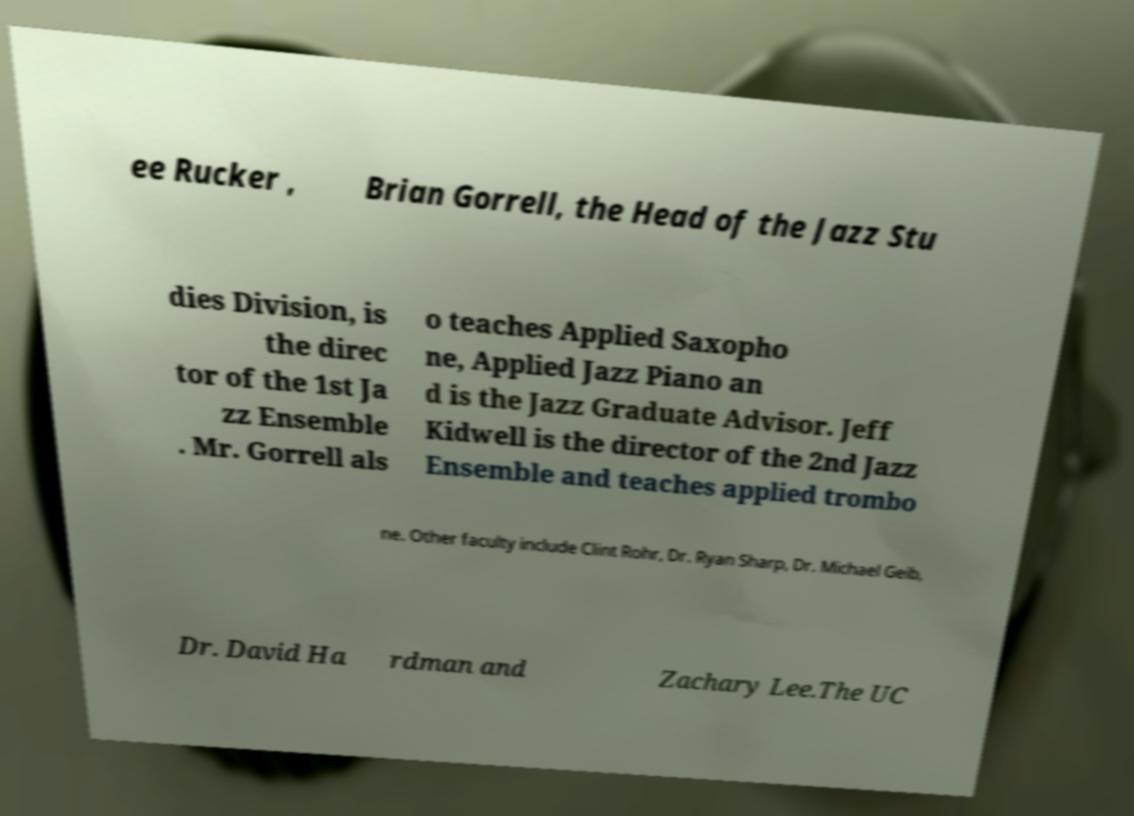Please read and relay the text visible in this image. What does it say? ee Rucker , Brian Gorrell, the Head of the Jazz Stu dies Division, is the direc tor of the 1st Ja zz Ensemble . Mr. Gorrell als o teaches Applied Saxopho ne, Applied Jazz Piano an d is the Jazz Graduate Advisor. Jeff Kidwell is the director of the 2nd Jazz Ensemble and teaches applied trombo ne. Other faculty include Clint Rohr, Dr. Ryan Sharp, Dr. Michael Geib, Dr. David Ha rdman and Zachary Lee.The UC 